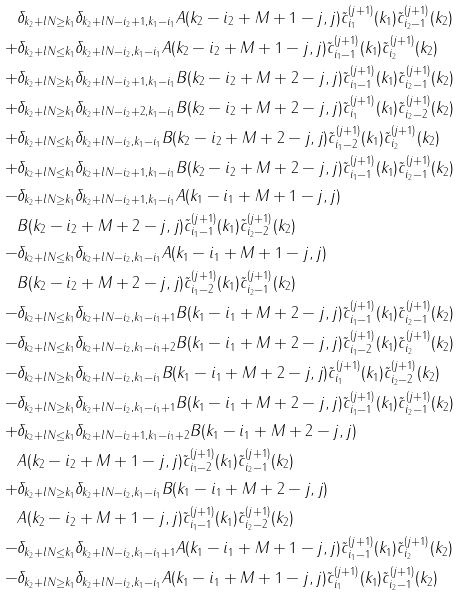<formula> <loc_0><loc_0><loc_500><loc_500>& \delta _ { k _ { 2 } + l N \geq k _ { 1 } } \delta _ { k _ { 2 } + l N - i _ { 2 } + 1 , k _ { 1 } - i _ { 1 } } A ( k _ { 2 } - i _ { 2 } + M + 1 - j , j ) \tilde { c } _ { i _ { 1 } } ^ { ( j + 1 ) } ( k _ { 1 } ) \tilde { c } _ { i _ { 2 } - 1 } ^ { ( j + 1 ) } ( k _ { 2 } ) \\ + & \delta _ { k _ { 2 } + l N \leq k _ { 1 } } \delta _ { k _ { 2 } + l N - i _ { 2 } , k _ { 1 } - i _ { 1 } } A ( k _ { 2 } - i _ { 2 } + M + 1 - j , j ) \tilde { c } _ { i _ { 1 } - 1 } ^ { ( j + 1 ) } ( k _ { 1 } ) \tilde { c } _ { i _ { 2 } } ^ { ( j + 1 ) } ( k _ { 2 } ) \\ + & \delta _ { k _ { 2 } + l N \geq k _ { 1 } } \delta _ { k _ { 2 } + l N - i _ { 2 } + 1 , k _ { 1 } - i _ { 1 } } B ( k _ { 2 } - i _ { 2 } + M + 2 - j , j ) \tilde { c } _ { i _ { 1 } - 1 } ^ { ( j + 1 ) } ( k _ { 1 } ) \tilde { c } _ { i _ { 2 } - 1 } ^ { ( j + 1 ) } ( k _ { 2 } ) \\ + & \delta _ { k _ { 2 } + l N \geq k _ { 1 } } \delta _ { k _ { 2 } + l N - i _ { 2 } + 2 , k _ { 1 } - i _ { 1 } } B ( k _ { 2 } - i _ { 2 } + M + 2 - j , j ) \tilde { c } _ { i _ { 1 } } ^ { ( j + 1 ) } ( k _ { 1 } ) \tilde { c } _ { i _ { 2 } - 2 } ^ { ( j + 1 ) } ( k _ { 2 } ) \\ + & \delta _ { k _ { 2 } + l N \leq k _ { 1 } } \delta _ { k _ { 2 } + l N - i _ { 2 } , k _ { 1 } - i _ { 1 } } B ( k _ { 2 } - i _ { 2 } + M + 2 - j , j ) \tilde { c } _ { i _ { 1 } - 2 } ^ { ( j + 1 ) } ( k _ { 1 } ) \tilde { c } _ { i _ { 2 } } ^ { ( j + 1 ) } ( k _ { 2 } ) \\ + & \delta _ { k _ { 2 } + l N \leq k _ { 1 } } \delta _ { k _ { 2 } + l N - i _ { 2 } + 1 , k _ { 1 } - i _ { 1 } } B ( k _ { 2 } - i _ { 2 } + M + 2 - j , j ) \tilde { c } _ { i _ { 1 } - 1 } ^ { ( j + 1 ) } ( k _ { 1 } ) \tilde { c } _ { i _ { 2 } - 1 } ^ { ( j + 1 ) } ( k _ { 2 } ) \\ - & \delta _ { k _ { 2 } + l N \geq k _ { 1 } } \delta _ { k _ { 2 } + l N - i _ { 2 } + 1 , k _ { 1 } - i _ { 1 } } A ( k _ { 1 } - i _ { 1 } + M + 1 - j , j ) \\ & B ( k _ { 2 } - i _ { 2 } + M + 2 - j , j ) \tilde { c } _ { i _ { 1 } - 1 } ^ { ( j + 1 ) } ( k _ { 1 } ) \tilde { c } _ { i _ { 2 } - 2 } ^ { ( j + 1 ) } ( k _ { 2 } ) \\ - & \delta _ { k _ { 2 } + l N \leq k _ { 1 } } \delta _ { k _ { 2 } + l N - i _ { 2 } , k _ { 1 } - i _ { 1 } } A ( k _ { 1 } - i _ { 1 } + M + 1 - j , j ) \\ & B ( k _ { 2 } - i _ { 2 } + M + 2 - j , j ) \tilde { c } _ { i _ { 1 } - 2 } ^ { ( j + 1 ) } ( k _ { 1 } ) \tilde { c } _ { i _ { 2 } - 1 } ^ { ( j + 1 ) } ( k _ { 2 } ) \\ - & \delta _ { k _ { 2 } + l N \leq k _ { 1 } } \delta _ { k _ { 2 } + l N - i _ { 2 } , k _ { 1 } - i _ { 1 } + 1 } B ( k _ { 1 } - i _ { 1 } + M + 2 - j , j ) \tilde { c } _ { i _ { 1 } - 1 } ^ { ( j + 1 ) } ( k _ { 1 } ) \tilde { c } _ { i _ { 2 } - 1 } ^ { ( j + 1 ) } ( k _ { 2 } ) \\ - & \delta _ { k _ { 2 } + l N \leq k _ { 1 } } \delta _ { k _ { 2 } + l N - i _ { 2 } , k _ { 1 } - i _ { 1 } + 2 } B ( k _ { 1 } - i _ { 1 } + M + 2 - j , j ) \tilde { c } _ { i _ { 1 } - 2 } ^ { ( j + 1 ) } ( k _ { 1 } ) \tilde { c } _ { i _ { 2 } } ^ { ( j + 1 ) } ( k _ { 2 } ) \\ - & \delta _ { k _ { 2 } + l N \geq k _ { 1 } } \delta _ { k _ { 2 } + l N - i _ { 2 } , k _ { 1 } - i _ { 1 } } B ( k _ { 1 } - i _ { 1 } + M + 2 - j , j ) \tilde { c } _ { i _ { 1 } } ^ { ( j + 1 ) } ( k _ { 1 } ) \tilde { c } _ { i _ { 2 } - 2 } ^ { ( j + 1 ) } ( k _ { 2 } ) \\ - & \delta _ { k _ { 2 } + l N \geq k _ { 1 } } \delta _ { k _ { 2 } + l N - i _ { 2 } , k _ { 1 } - i _ { 1 } + 1 } B ( k _ { 1 } - i _ { 1 } + M + 2 - j , j ) \tilde { c } _ { i _ { 1 } - 1 } ^ { ( j + 1 ) } ( k _ { 1 } ) \tilde { c } _ { i _ { 2 } - 1 } ^ { ( j + 1 ) } ( k _ { 2 } ) \\ + & \delta _ { k _ { 2 } + l N \leq k _ { 1 } } \delta _ { k _ { 2 } + l N - i _ { 2 } + 1 , k _ { 1 } - i _ { 1 } + 2 } B ( k _ { 1 } - i _ { 1 } + M + 2 - j , j ) \\ & A ( k _ { 2 } - i _ { 2 } + M + 1 - j , j ) \tilde { c } _ { i _ { 1 } - 2 } ^ { ( j + 1 ) } ( k _ { 1 } ) \tilde { c } _ { i _ { 2 } - 1 } ^ { ( j + 1 ) } ( k _ { 2 } ) \\ + & \delta _ { k _ { 2 } + l N \geq k _ { 1 } } \delta _ { k _ { 2 } + l N - i _ { 2 } , k _ { 1 } - i _ { 1 } } B ( k _ { 1 } - i _ { 1 } + M + 2 - j , j ) \\ & A ( k _ { 2 } - i _ { 2 } + M + 1 - j , j ) \tilde { c } _ { i _ { 1 } - 1 } ^ { ( j + 1 ) } ( k _ { 1 } ) \tilde { c } _ { i _ { 2 } - 2 } ^ { ( j + 1 ) } ( k _ { 2 } ) \\ - & \delta _ { k _ { 2 } + l N \leq k _ { 1 } } \delta _ { k _ { 2 } + l N - i _ { 2 } , k _ { 1 } - i _ { 1 } + 1 } A ( k _ { 1 } - i _ { 1 } + M + 1 - j , j ) \tilde { c } _ { i _ { 1 } - 1 } ^ { ( j + 1 ) } ( k _ { 1 } ) \tilde { c } _ { i _ { 2 } } ^ { ( j + 1 ) } ( k _ { 2 } ) \\ - & \delta _ { k _ { 2 } + l N \geq k _ { 1 } } \delta _ { k _ { 2 } + l N - i _ { 2 } , k _ { 1 } - i _ { 1 } } A ( k _ { 1 } - i _ { 1 } + M + 1 - j , j ) \tilde { c } _ { i _ { 1 } } ^ { ( j + 1 ) } ( k _ { 1 } ) \tilde { c } _ { i _ { 2 } - 1 } ^ { ( j + 1 ) } ( k _ { 2 } ) \\</formula> 